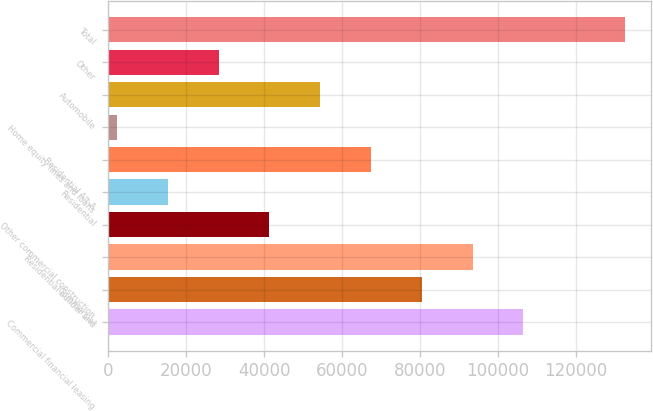<chart> <loc_0><loc_0><loc_500><loc_500><bar_chart><fcel>Commercial financial leasing<fcel>Commercial<fcel>Residential builder and<fcel>Other commercial construction<fcel>Residential<fcel>Residential Alt-A<fcel>Home equity lines and loans<fcel>Automobile<fcel>Other<fcel>Total<nl><fcel>106596<fcel>80510.8<fcel>93553.6<fcel>41382.4<fcel>15296.8<fcel>67468<fcel>2254<fcel>54425.2<fcel>28339.6<fcel>132682<nl></chart> 